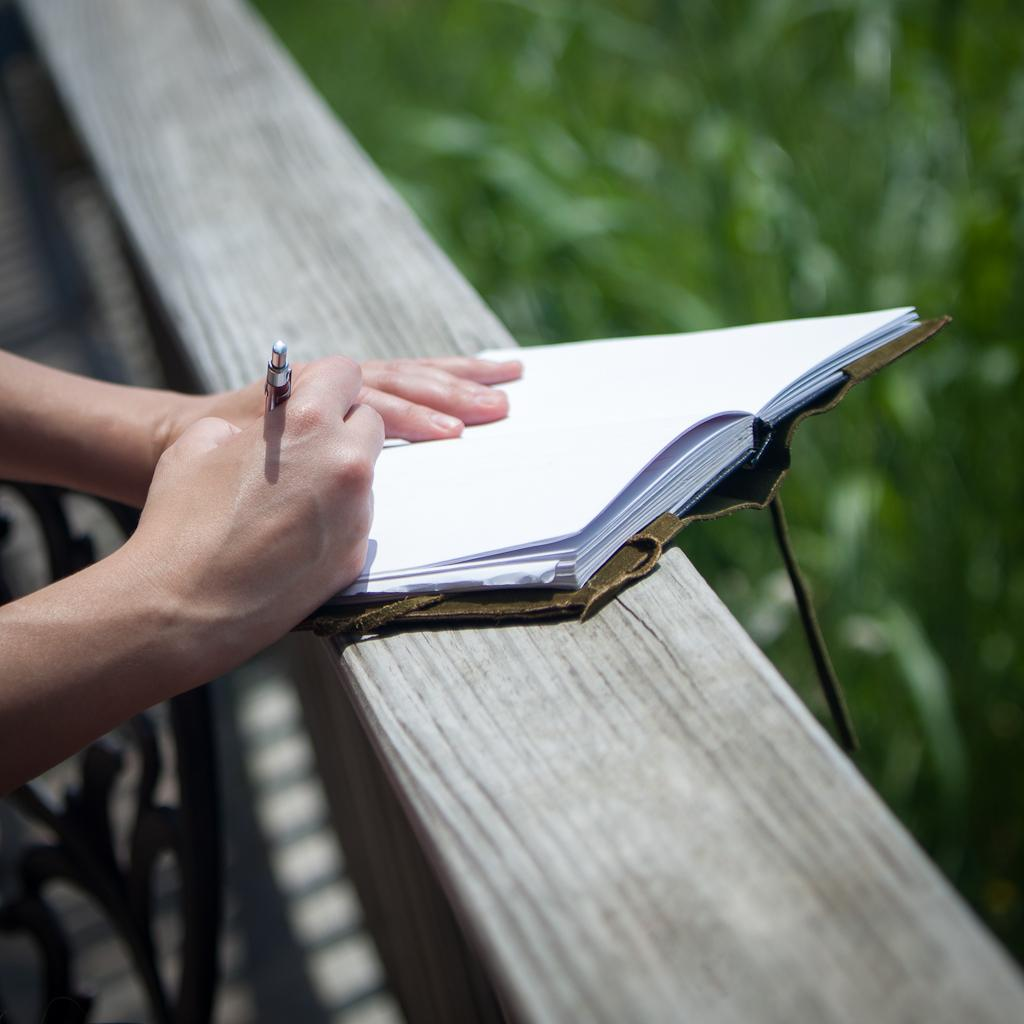What is the person in the image doing? The person is writing in a book. What tool is the person using to write? The person is using a pen. Can you describe the setting in which the person is writing? There appears to be a chair in the image, which suggests the person may be sitting while writing. What is the rate of the war happening in the image? There is no war present in the image; it features a person writing in a book. How many hours does the person spend writing in the image? The image does not provide information about the duration of the person's writing session. 